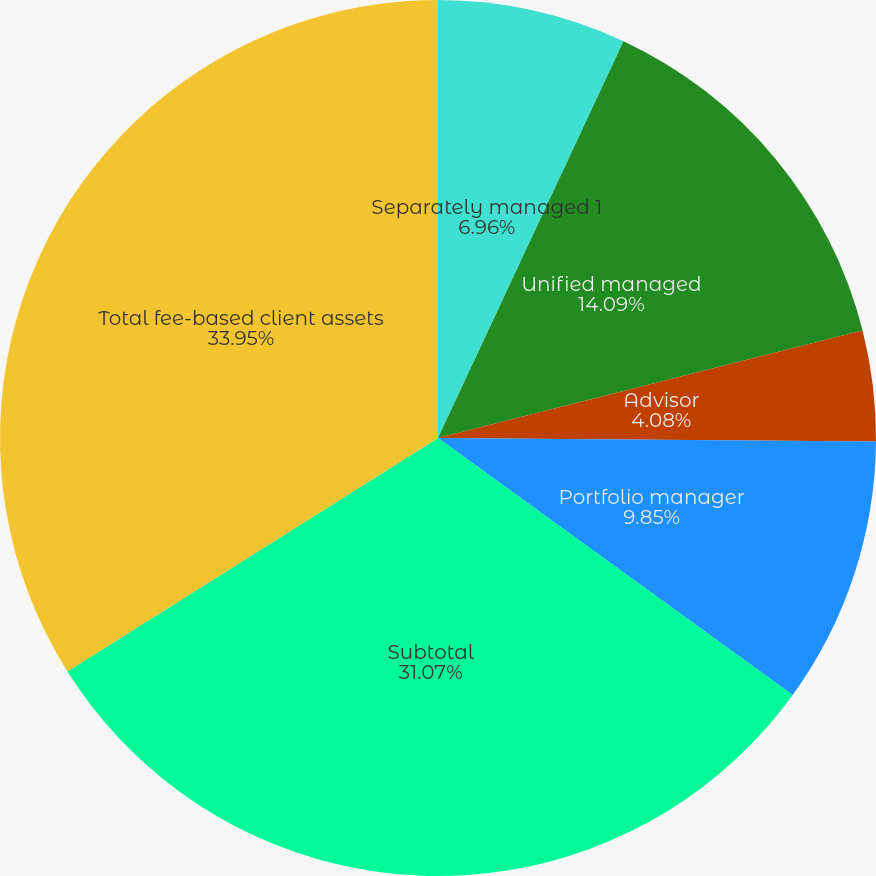Convert chart to OTSL. <chart><loc_0><loc_0><loc_500><loc_500><pie_chart><fcel>Separately managed 1<fcel>Unified managed<fcel>Advisor<fcel>Portfolio manager<fcel>Subtotal<fcel>Total fee-based client assets<nl><fcel>6.96%<fcel>14.09%<fcel>4.08%<fcel>9.85%<fcel>31.07%<fcel>33.95%<nl></chart> 